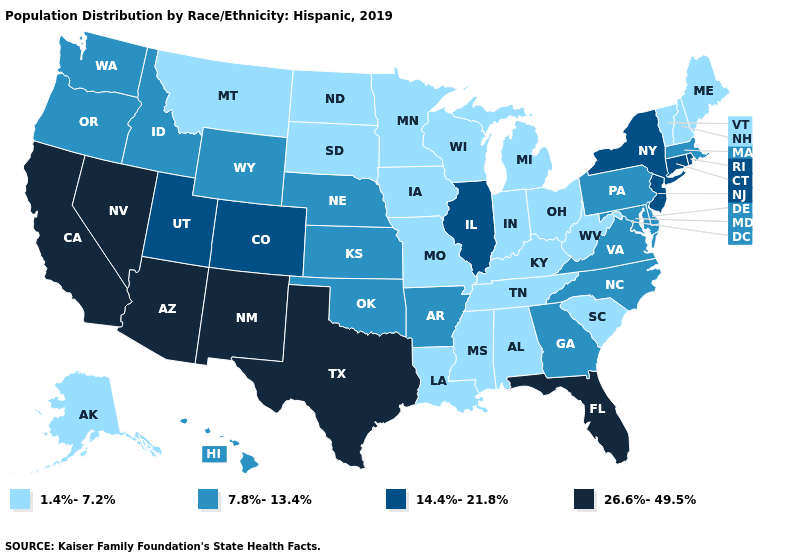Does the first symbol in the legend represent the smallest category?
Short answer required. Yes. What is the value of Connecticut?
Give a very brief answer. 14.4%-21.8%. Among the states that border Florida , does Georgia have the highest value?
Write a very short answer. Yes. What is the value of Rhode Island?
Be succinct. 14.4%-21.8%. What is the highest value in the USA?
Answer briefly. 26.6%-49.5%. Which states have the highest value in the USA?
Give a very brief answer. Arizona, California, Florida, Nevada, New Mexico, Texas. Name the states that have a value in the range 1.4%-7.2%?
Give a very brief answer. Alabama, Alaska, Indiana, Iowa, Kentucky, Louisiana, Maine, Michigan, Minnesota, Mississippi, Missouri, Montana, New Hampshire, North Dakota, Ohio, South Carolina, South Dakota, Tennessee, Vermont, West Virginia, Wisconsin. Name the states that have a value in the range 14.4%-21.8%?
Short answer required. Colorado, Connecticut, Illinois, New Jersey, New York, Rhode Island, Utah. What is the highest value in the USA?
Give a very brief answer. 26.6%-49.5%. What is the value of Michigan?
Short answer required. 1.4%-7.2%. Name the states that have a value in the range 1.4%-7.2%?
Give a very brief answer. Alabama, Alaska, Indiana, Iowa, Kentucky, Louisiana, Maine, Michigan, Minnesota, Mississippi, Missouri, Montana, New Hampshire, North Dakota, Ohio, South Carolina, South Dakota, Tennessee, Vermont, West Virginia, Wisconsin. Does Delaware have a lower value than Massachusetts?
Quick response, please. No. Name the states that have a value in the range 7.8%-13.4%?
Quick response, please. Arkansas, Delaware, Georgia, Hawaii, Idaho, Kansas, Maryland, Massachusetts, Nebraska, North Carolina, Oklahoma, Oregon, Pennsylvania, Virginia, Washington, Wyoming. Name the states that have a value in the range 26.6%-49.5%?
Be succinct. Arizona, California, Florida, Nevada, New Mexico, Texas. What is the lowest value in states that border Michigan?
Quick response, please. 1.4%-7.2%. 